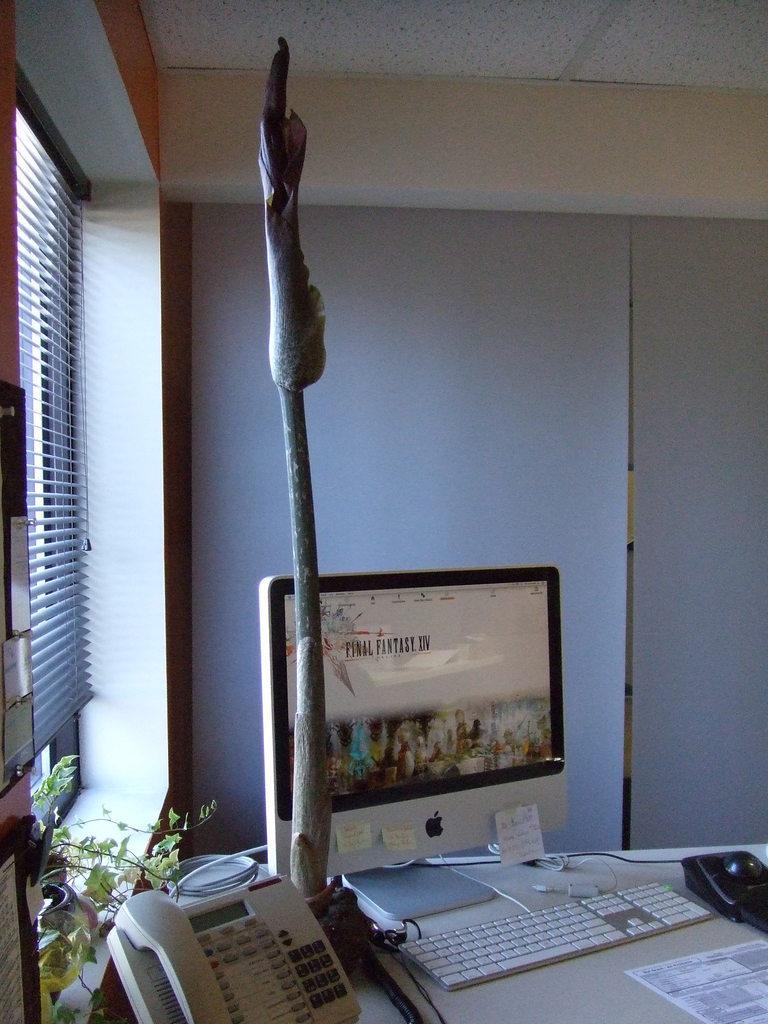Describe this image in one or two sentences. In this image there is a table towards the bottom of the image, there is a paper on the table, there is a keyboard on the table, there is a monitor on the table, there is a telephone on the table, there is a wire on the table, there are objects on the table, there is a flower pot towards the left of the image, there is a plant, there are objects towards the left of the image, there is a window, there is a blind, there is a wall, there is a roof towards the top of the image. 